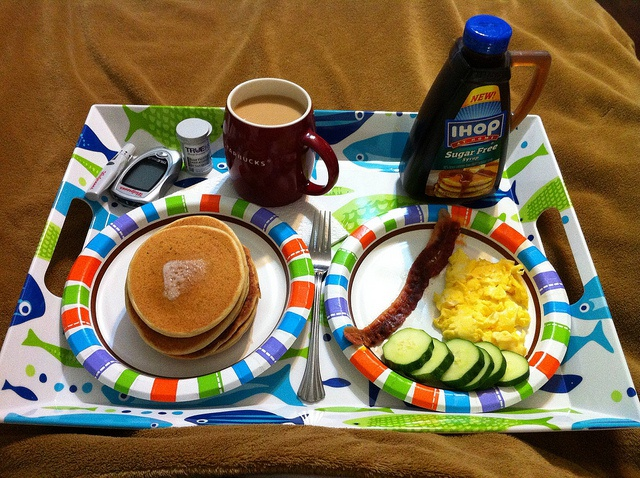Describe the objects in this image and their specific colors. I can see bottle in maroon, black, navy, and olive tones, cup in maroon, black, tan, and gray tones, fork in maroon, gray, lightgray, and darkgray tones, and cell phone in maroon, black, darkgray, gray, and purple tones in this image. 